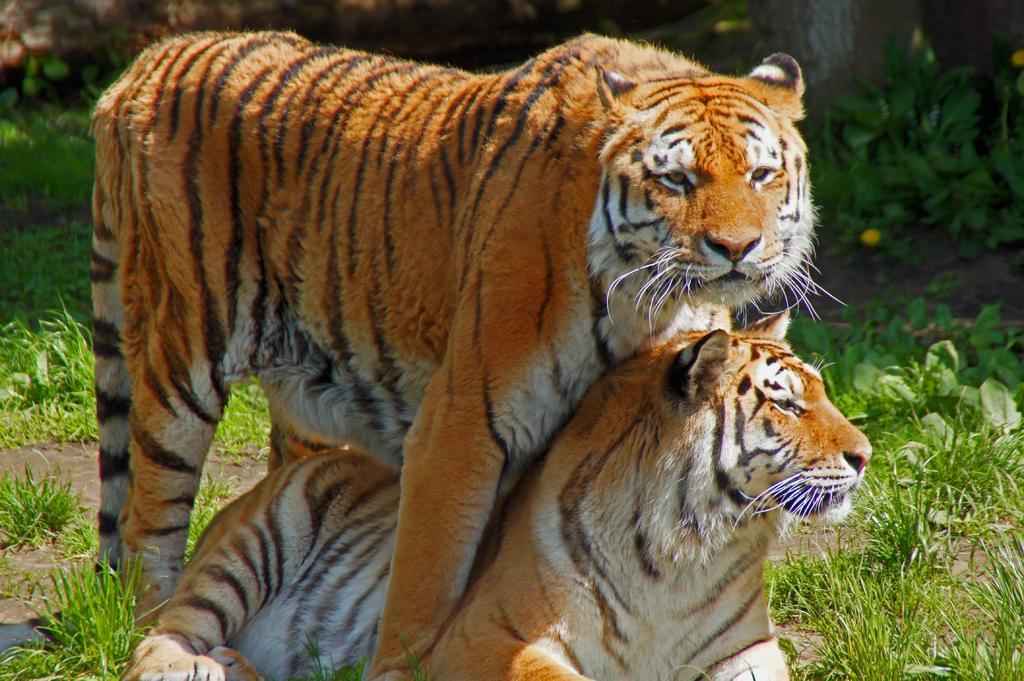In one or two sentences, can you explain what this image depicts? In the picture there are two tigers, beside the tigers there are plants present. 